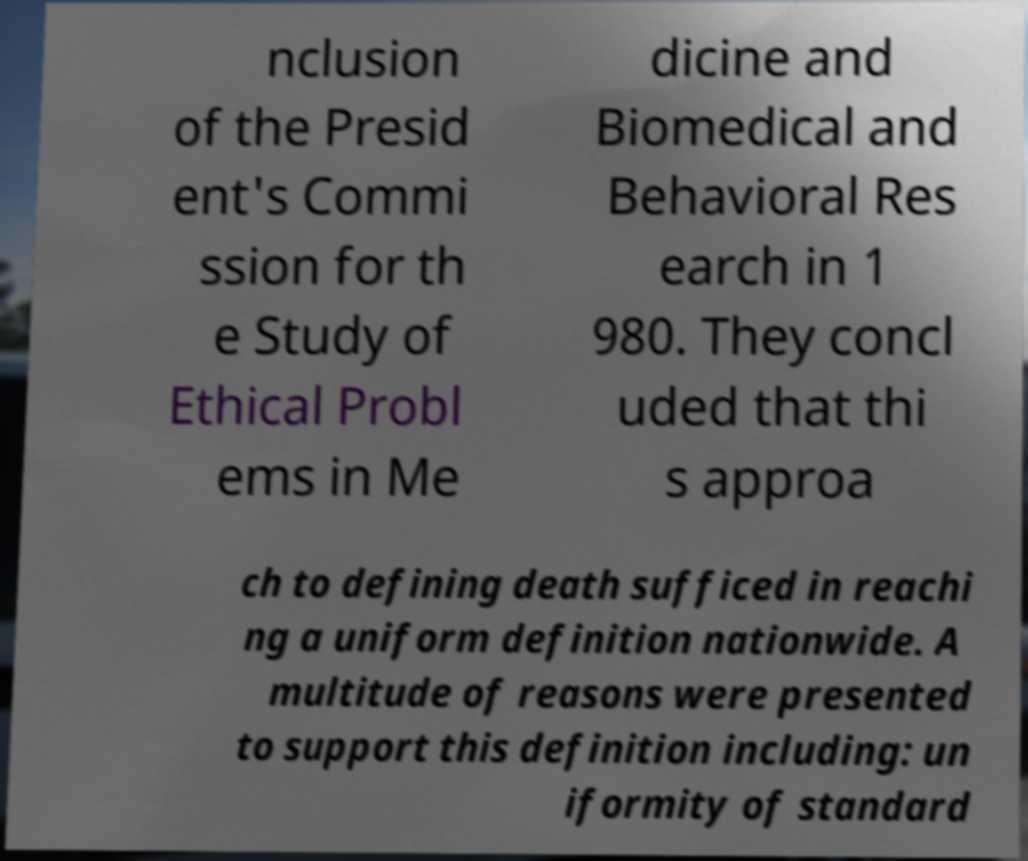There's text embedded in this image that I need extracted. Can you transcribe it verbatim? nclusion of the Presid ent's Commi ssion for th e Study of Ethical Probl ems in Me dicine and Biomedical and Behavioral Res earch in 1 980. They concl uded that thi s approa ch to defining death sufficed in reachi ng a uniform definition nationwide. A multitude of reasons were presented to support this definition including: un iformity of standard 